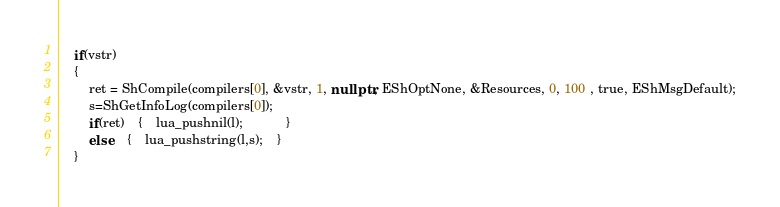<code> <loc_0><loc_0><loc_500><loc_500><_C++_>
	if(vstr)
	{
		ret = ShCompile(compilers[0], &vstr, 1, nullptr, EShOptNone, &Resources, 0, 100 , true, EShMsgDefault);
		s=ShGetInfoLog(compilers[0]);
		if(ret)	{	lua_pushnil(l);			}
		else	{	lua_pushstring(l,s);	}
	}</code> 